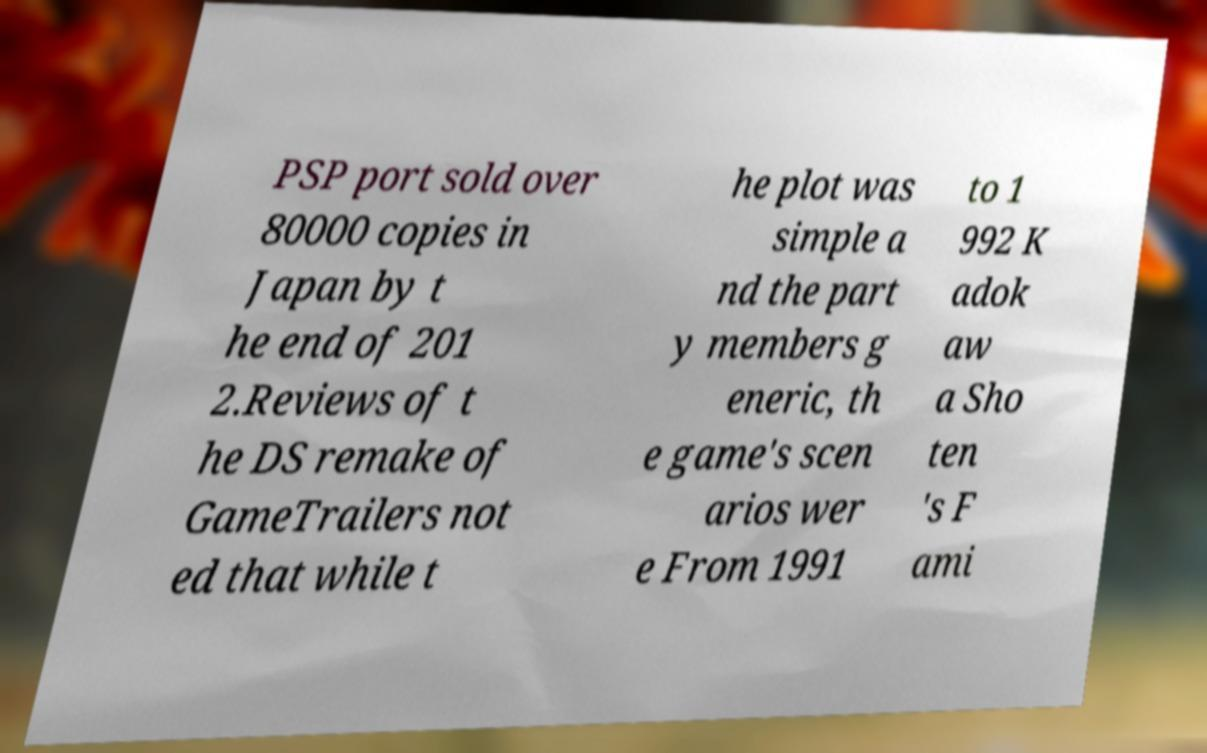Can you accurately transcribe the text from the provided image for me? PSP port sold over 80000 copies in Japan by t he end of 201 2.Reviews of t he DS remake of GameTrailers not ed that while t he plot was simple a nd the part y members g eneric, th e game's scen arios wer e From 1991 to 1 992 K adok aw a Sho ten 's F ami 